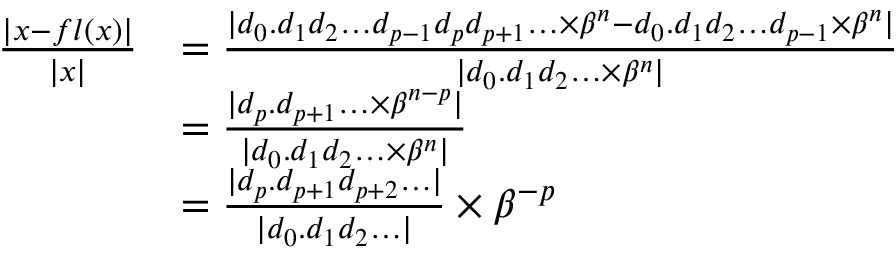<formula> <loc_0><loc_0><loc_500><loc_500>{ \begin{array} { r l } { { \frac { | x - f l ( x ) | } { | x | } } } & { = { \frac { | d _ { 0 } . d _ { 1 } d _ { 2 } \dots d _ { p - 1 } d _ { p } d _ { p + 1 } \dots \times \beta ^ { n } - d _ { 0 } . d _ { 1 } d _ { 2 } \dots d _ { p - 1 } \times \beta ^ { n } | } { | d _ { 0 } . d _ { 1 } d _ { 2 } \dots \times \beta ^ { n } | } } } \\ & { = { \frac { | d _ { p } . d _ { p + 1 } \dots \times \beta ^ { n - p } | } { | d _ { 0 } . d _ { 1 } d _ { 2 } \dots \times \beta ^ { n } | } } } \\ & { = { \frac { | d _ { p } . d _ { p + 1 } d _ { p + 2 } \dots | } { | d _ { 0 } . d _ { 1 } d _ { 2 } \dots | } } \times \beta ^ { - p } } \end{array} }</formula> 